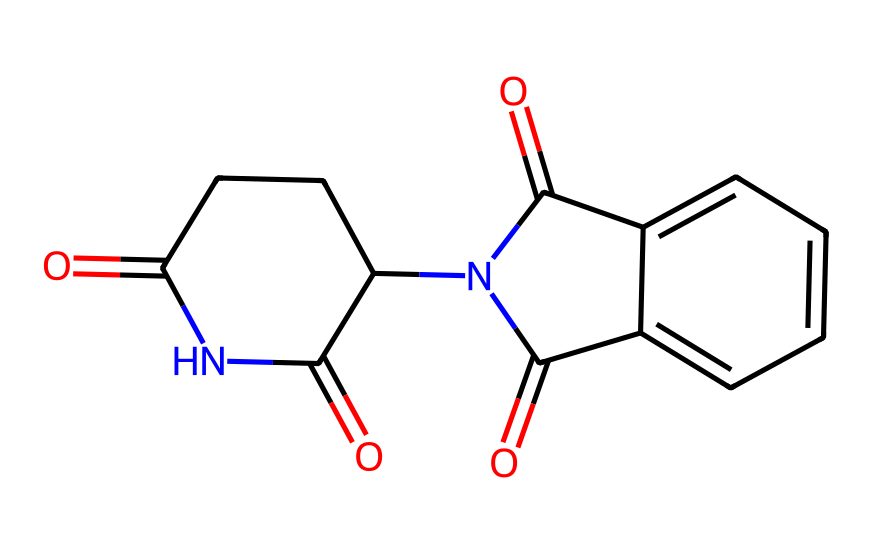What is the primary functional group present in thalidomide? The SMILES representation indicates that thalidomide includes an imide functional group, characterized by a cyclic structure where carbonyl (C=O) groups are attached to the nitrogen atom within a ring.
Answer: imide How many carbon atoms are in the molecular structure of thalidomide? By analyzing the SMILES, we can count the carbon atoms represented. There are a total of 13 carbon atoms present in the structure.
Answer: 13 What type of ring structure is present in thalidomide? The presence of the carbon and nitrogen atoms in a cyclical arrangement indicates that thalidomide contains a five-membered ring structure known as a cyclic imide.
Answer: cyclic How many nitrogen atoms are present in thalidomide? The SMILES representation includes two nitrogen atoms, which can be seen as part of the imide functional group indicating the presence of nitrogen in the ring structure.
Answer: 2 What linkage connects the imide group to the phenyl ring in thalidomide? The connection from the imide to the phenyl ring is through a carbon atom, forming a carbon-carbon single bond that integrates the phenyl group into the larger imide structure.
Answer: carbon-carbon bond Is thalidomide a symmetrical molecule? The examination of the molecular structure shows that the imide portion is not mirrored on either side of the molecule, indicating that it lacks symmetry.
Answer: no What are the two carbonyl groups in thalidomide derived from? The two carbonyl groups are derived from the imide functional group, which includes two carbonyl functionalities attached to the nitrogen within the cyclic structure.
Answer: imide functional group 